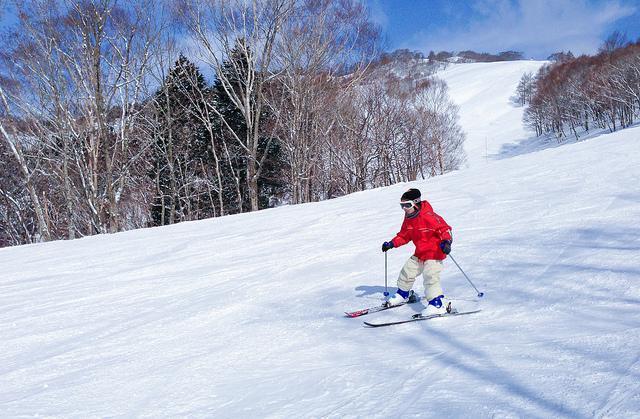How many people are there?
Give a very brief answer. 1. 